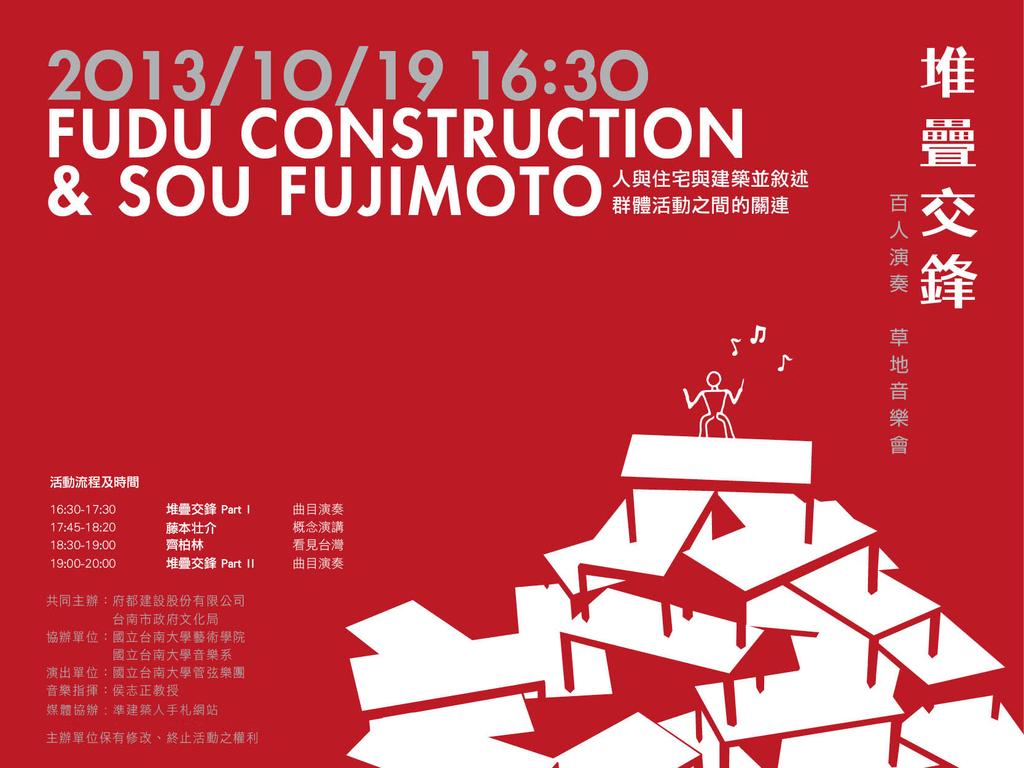What year is shown on this photo?
Offer a very short reply. 2013. What is the word before construction?
Provide a succinct answer. Fudu. 